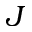Convert formula to latex. <formula><loc_0><loc_0><loc_500><loc_500>J</formula> 